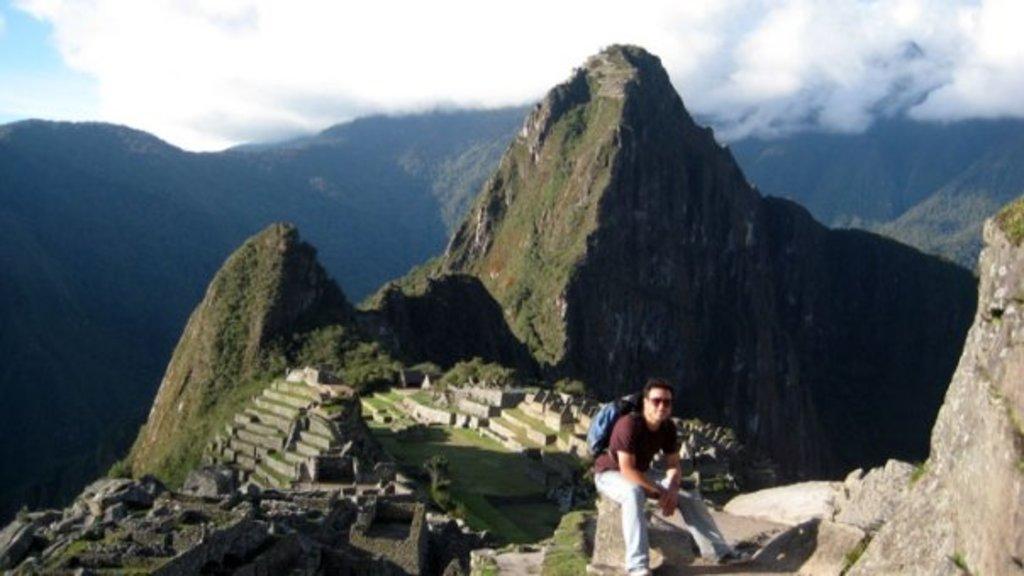Describe this image in one or two sentences. In this picture we can see a person, he is wearing a bag, here we can see rocks, grass and in the background we can see mountains, sky with clouds. 